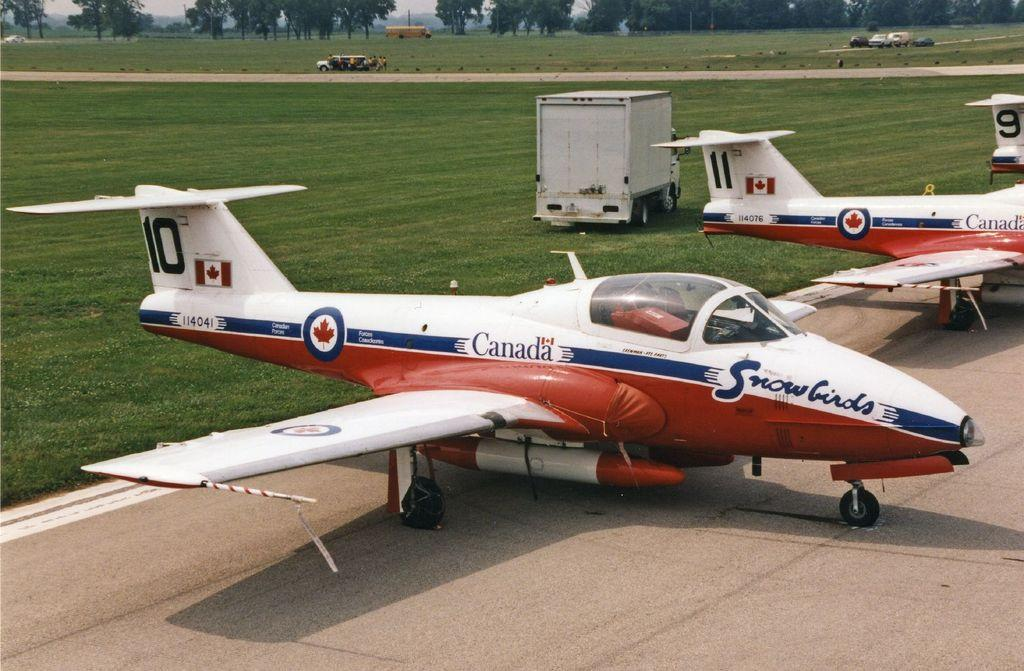Provide a one-sentence caption for the provided image. The Canadian Snowbirds fleet is parked next to each other in numerical order. 